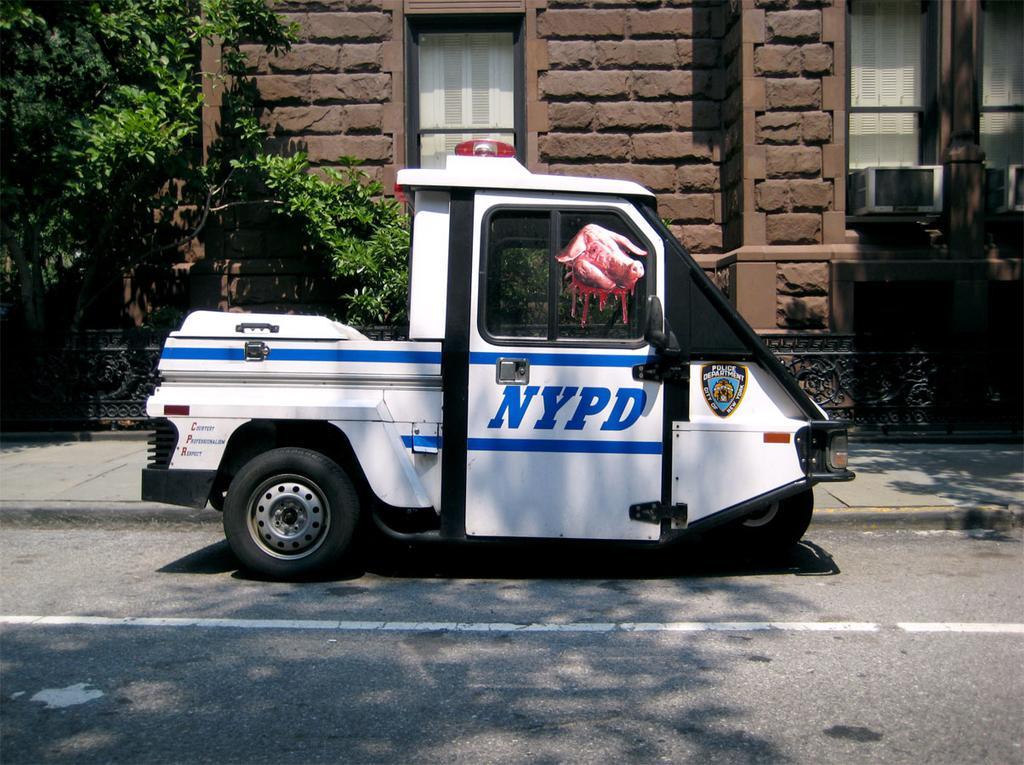How would you summarize this image in a sentence or two? In this image in the center of there is a vehicle, and in the background there is a house, window, air conditioner, trees. And at the bottom there is road. 